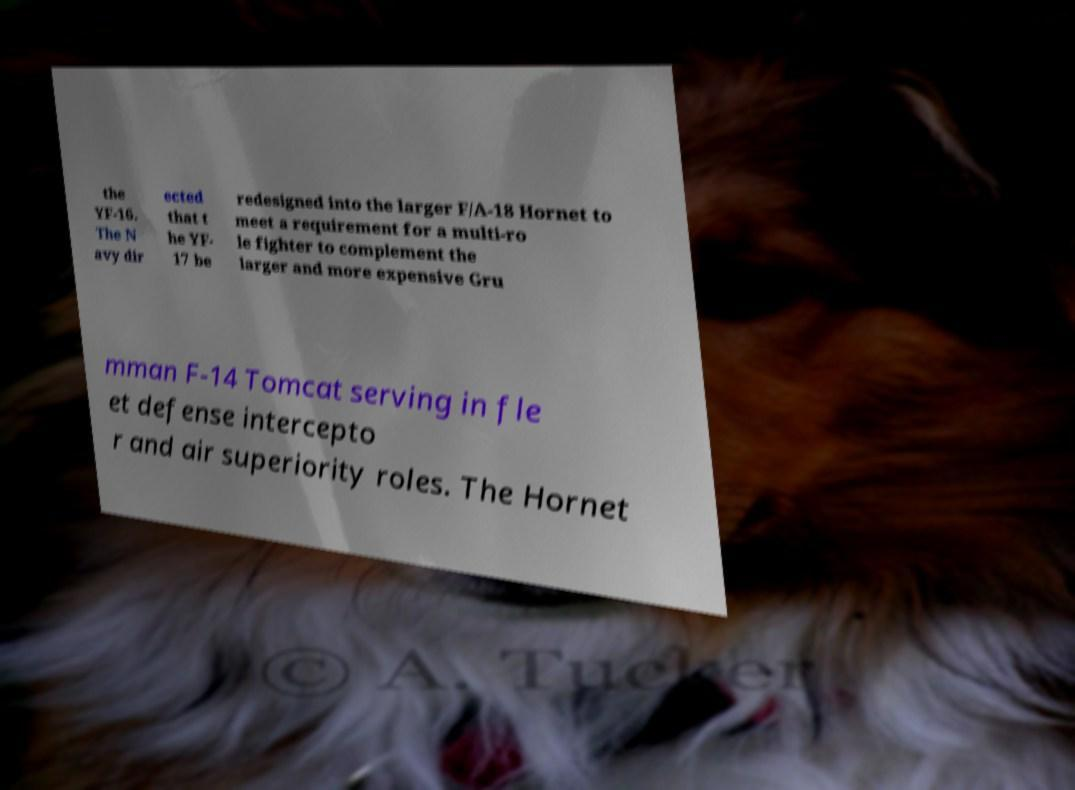Please identify and transcribe the text found in this image. the YF-16. The N avy dir ected that t he YF- 17 be redesigned into the larger F/A-18 Hornet to meet a requirement for a multi-ro le fighter to complement the larger and more expensive Gru mman F-14 Tomcat serving in fle et defense intercepto r and air superiority roles. The Hornet 